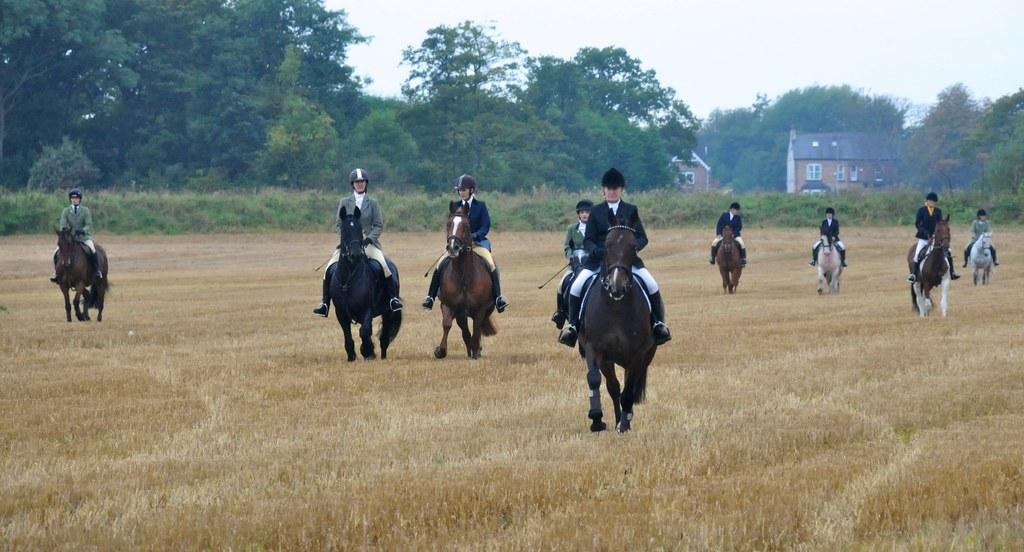What are the people in the image doing? The people in the image are sitting on horses. What is the terrain like where the horses are riding? The horses are riding on dry grass. What can be seen in the background of the image? There are shrubs, trees, wooden houses, and the sky visible in the background of the image. What is the rate at which the dolls are falling in the image? There are no dolls present in the image, so it is not possible to determine a rate at which they might be falling. 